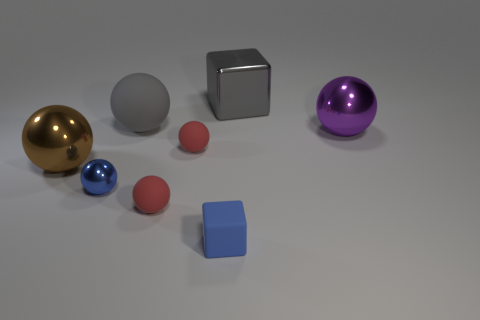What is the shape of the large thing that is the same color as the large shiny block?
Your answer should be very brief. Sphere. Is the size of the block left of the gray block the same as the brown metallic ball?
Offer a very short reply. No. Are there an equal number of small blue cubes behind the small blue cube and balls?
Ensure brevity in your answer.  No. How many things are small blue things that are behind the rubber cube or tiny spheres?
Give a very brief answer. 3. There is a shiny thing that is both behind the blue metallic object and in front of the purple ball; what is its shape?
Keep it short and to the point. Sphere. How many things are tiny blue metallic spheres behind the matte cube or matte objects that are in front of the brown metallic object?
Your response must be concise. 3. How many other objects are there of the same size as the metallic cube?
Provide a short and direct response. 3. There is a large shiny sphere on the right side of the tiny blue rubber cube; does it have the same color as the small rubber block?
Make the answer very short. No. What is the size of the rubber ball that is both on the right side of the big matte object and behind the big brown metal ball?
Your answer should be compact. Small. What number of large objects are either brown blocks or blue rubber things?
Your answer should be compact. 0. 